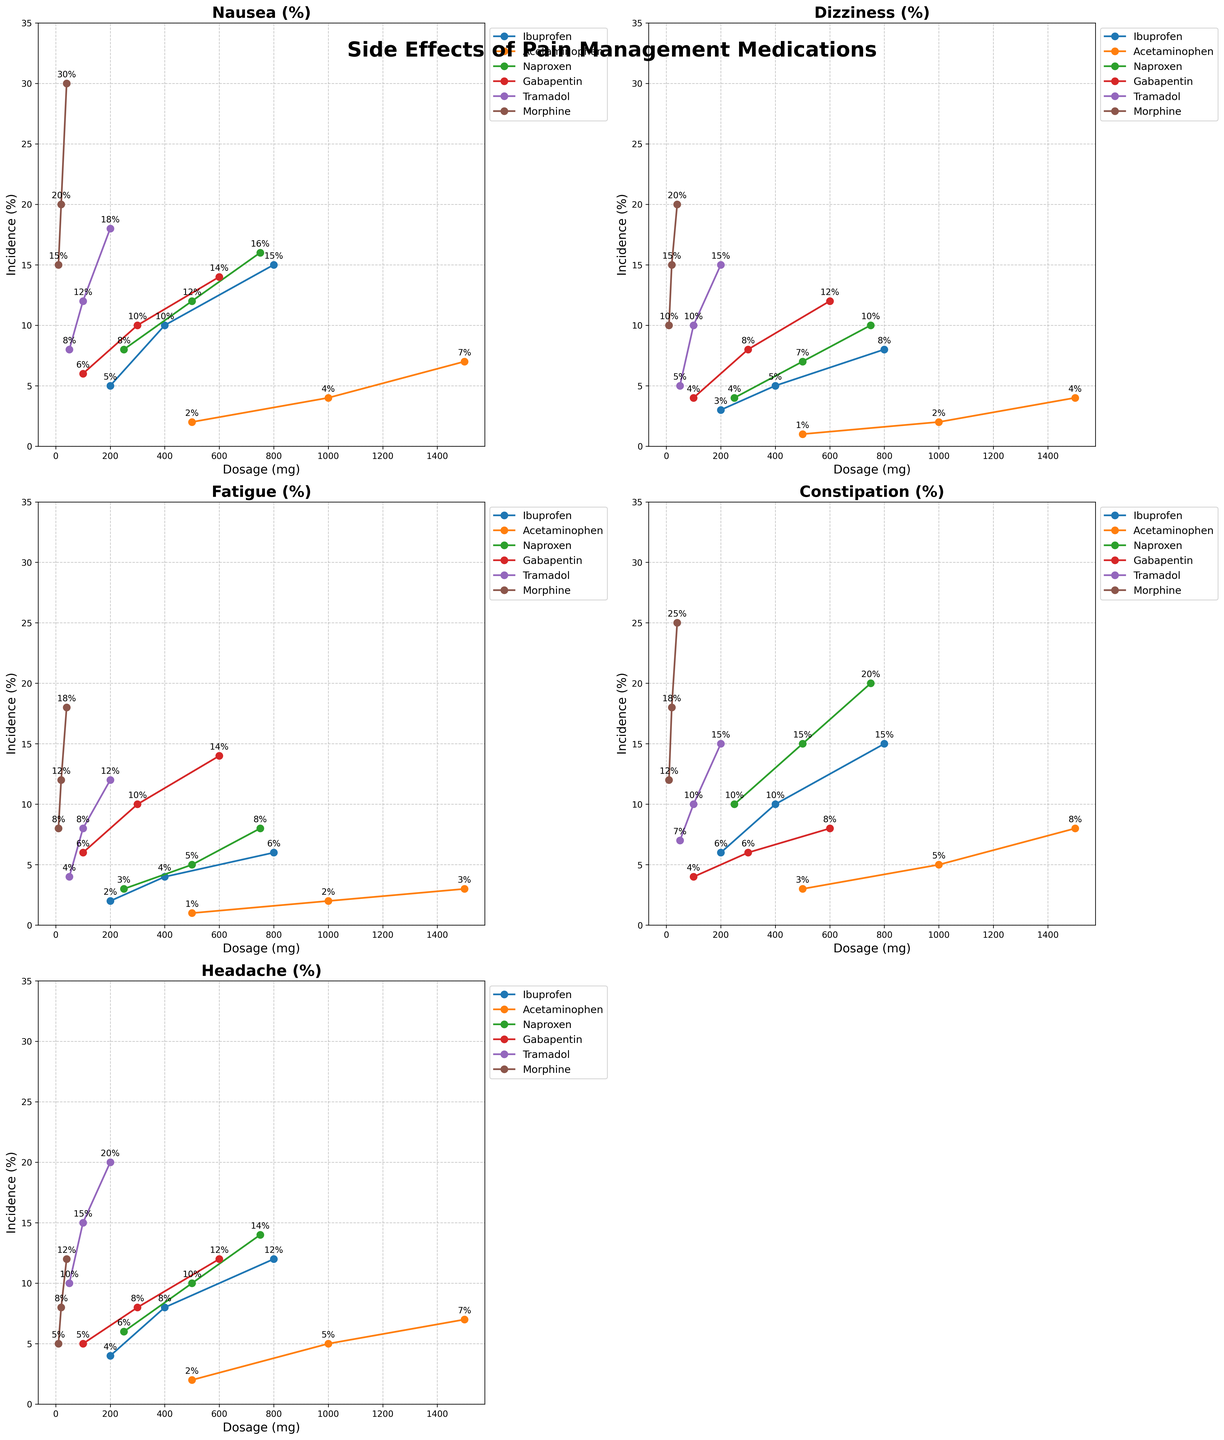What's the title of the figure? The title of the figure is clearly labeled at the top.
Answer: Side Effects of Pain Management Medications Which medication has the highest incidence of nausea at its highest dosage? By looking at the nausea subplot, we find the highest dosage points for each medication and compare their nausea incidence rates. Morphine at 40 mg has the highest rate of 30%.
Answer: Morphine At what dosage does Ibuprofen reach a headache incidence rate of 12%? On the headache subplot, find the point where the Ibuprofen line intersects with 12% incidence. The corresponding dosage is 800 mg.
Answer: 800 mg Comparing Gabapentin and Tramadol, which has a higher incidence of fatigue at their middle dosage levels? Identify the middle dosages for Gabapentin (300 mg) and Tramadol (100 mg) on the fatigue subplot and compare the incidence rates. Gabapentin at 300 mg has a 10% incidence, while Tramadol at 100 mg has an 8% incidence.
Answer: Gabapentin What is the difference in the incidence rate of dizziness between Naproxen at its highest dosage and Ibuprofen at its highest dosage? On the dizziness subplot, locate the highest dosages for Naproxen (750 mg) and Ibuprofen (800 mg) and note their incidence rates: 10% for Naproxen and 8% for Ibuprofen. The difference is 16 - 8 = 8%.
Answer: 8% Which side effect has the lowest overall maximum incidence rate across all medications and dosages? Check the maximum incidence rates for all side effects in their respective subplots. Fatigue has the lowest maximum incidence rate at 18%.
Answer: Fatigue What is the pattern of the side effects for Morphine as the dosage increases? Examine the subplots for Morphine and observe the trend as dosage increases from 10 mg to 40 mg. Incidence rates for all side effects (Nausea, Dizziness, Fatigue, Constipation, and Headache) increase with dosage.
Answer: Increasing How does the incidence rate of constipation for Acetaminophen compare to Gabapentin at their lowest dosages? On the constipation subplot, compare 500 mg of Acetaminophen with 100 mg of Gabapentin. Acetaminophen has a rate of 3%, while Gabapentin has a 4% incidence rate.
Answer: Gabapentin is higher Which medication shows the smallest increase in dizziness incidence from the lowest to the highest dosage? Calculate the increase in dizziness incidence for each medication and compare. Acetaminophen increases from 1% to 4%, an increase of 3%, which is the smallest among all medications.
Answer: Acetaminophen 